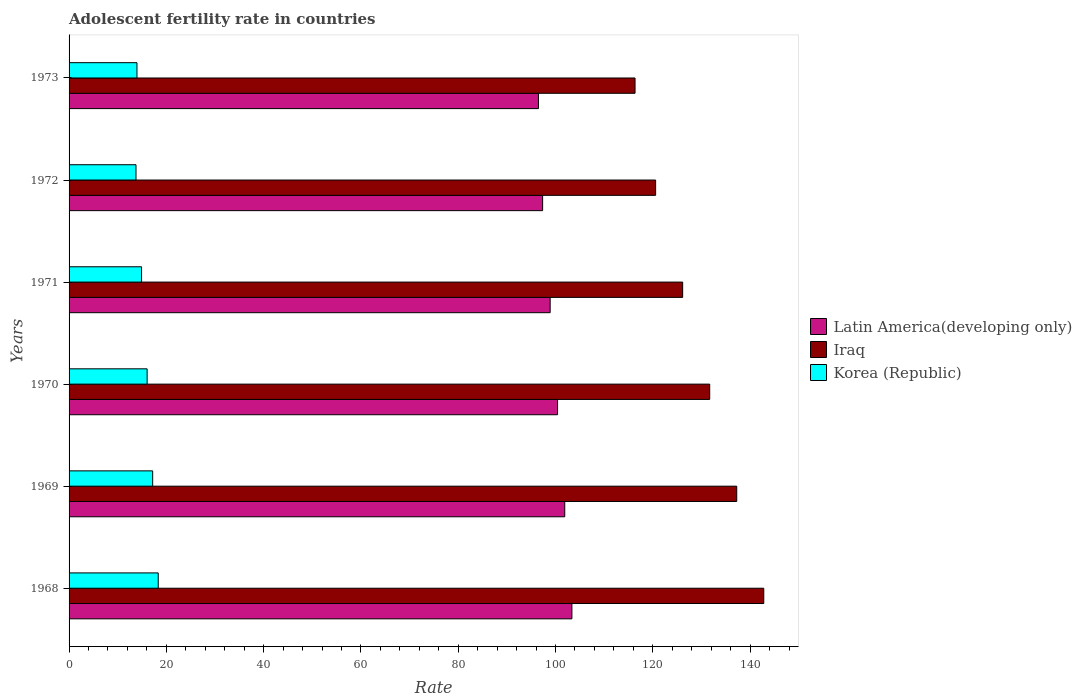How many different coloured bars are there?
Your response must be concise. 3. How many groups of bars are there?
Ensure brevity in your answer.  6. Are the number of bars per tick equal to the number of legend labels?
Ensure brevity in your answer.  Yes. Are the number of bars on each tick of the Y-axis equal?
Your response must be concise. Yes. What is the label of the 4th group of bars from the top?
Offer a terse response. 1970. In how many cases, is the number of bars for a given year not equal to the number of legend labels?
Your answer should be compact. 0. What is the adolescent fertility rate in Korea (Republic) in 1971?
Provide a short and direct response. 14.9. Across all years, what is the maximum adolescent fertility rate in Korea (Republic)?
Provide a short and direct response. 18.33. Across all years, what is the minimum adolescent fertility rate in Iraq?
Your response must be concise. 116.35. In which year was the adolescent fertility rate in Korea (Republic) maximum?
Your answer should be very brief. 1968. What is the total adolescent fertility rate in Latin America(developing only) in the graph?
Provide a succinct answer. 598.43. What is the difference between the adolescent fertility rate in Korea (Republic) in 1972 and that in 1973?
Make the answer very short. -0.2. What is the difference between the adolescent fertility rate in Latin America(developing only) in 1971 and the adolescent fertility rate in Iraq in 1972?
Your answer should be very brief. -21.68. What is the average adolescent fertility rate in Korea (Republic) per year?
Your answer should be compact. 15.7. In the year 1972, what is the difference between the adolescent fertility rate in Korea (Republic) and adolescent fertility rate in Latin America(developing only)?
Your answer should be compact. -83.59. What is the ratio of the adolescent fertility rate in Korea (Republic) in 1969 to that in 1972?
Offer a terse response. 1.25. Is the difference between the adolescent fertility rate in Korea (Republic) in 1968 and 1971 greater than the difference between the adolescent fertility rate in Latin America(developing only) in 1968 and 1971?
Offer a very short reply. No. What is the difference between the highest and the second highest adolescent fertility rate in Iraq?
Make the answer very short. 5.56. What is the difference between the highest and the lowest adolescent fertility rate in Latin America(developing only)?
Keep it short and to the point. 6.88. In how many years, is the adolescent fertility rate in Korea (Republic) greater than the average adolescent fertility rate in Korea (Republic) taken over all years?
Keep it short and to the point. 3. Is the sum of the adolescent fertility rate in Iraq in 1970 and 1972 greater than the maximum adolescent fertility rate in Korea (Republic) across all years?
Provide a succinct answer. Yes. What does the 2nd bar from the top in 1969 represents?
Keep it short and to the point. Iraq. What does the 2nd bar from the bottom in 1970 represents?
Provide a short and direct response. Iraq. Are all the bars in the graph horizontal?
Make the answer very short. Yes. How many years are there in the graph?
Keep it short and to the point. 6. Are the values on the major ticks of X-axis written in scientific E-notation?
Provide a succinct answer. No. Does the graph contain grids?
Make the answer very short. No. Where does the legend appear in the graph?
Offer a very short reply. Center right. How are the legend labels stacked?
Offer a terse response. Vertical. What is the title of the graph?
Make the answer very short. Adolescent fertility rate in countries. Does "Liechtenstein" appear as one of the legend labels in the graph?
Make the answer very short. No. What is the label or title of the X-axis?
Offer a terse response. Rate. What is the Rate of Latin America(developing only) in 1968?
Keep it short and to the point. 103.37. What is the Rate in Iraq in 1968?
Your answer should be very brief. 142.81. What is the Rate in Korea (Republic) in 1968?
Offer a terse response. 18.33. What is the Rate in Latin America(developing only) in 1969?
Offer a very short reply. 101.9. What is the Rate in Iraq in 1969?
Make the answer very short. 137.25. What is the Rate of Korea (Republic) in 1969?
Make the answer very short. 17.19. What is the Rate in Latin America(developing only) in 1970?
Ensure brevity in your answer.  100.42. What is the Rate in Iraq in 1970?
Give a very brief answer. 131.7. What is the Rate of Korea (Republic) in 1970?
Provide a succinct answer. 16.04. What is the Rate in Latin America(developing only) in 1971?
Give a very brief answer. 98.9. What is the Rate in Iraq in 1971?
Ensure brevity in your answer.  126.14. What is the Rate of Korea (Republic) in 1971?
Your response must be concise. 14.9. What is the Rate in Latin America(developing only) in 1972?
Offer a terse response. 97.35. What is the Rate of Iraq in 1972?
Give a very brief answer. 120.58. What is the Rate of Korea (Republic) in 1972?
Make the answer very short. 13.76. What is the Rate in Latin America(developing only) in 1973?
Your answer should be very brief. 96.49. What is the Rate in Iraq in 1973?
Provide a succinct answer. 116.35. What is the Rate of Korea (Republic) in 1973?
Your answer should be compact. 13.96. Across all years, what is the maximum Rate of Latin America(developing only)?
Give a very brief answer. 103.37. Across all years, what is the maximum Rate in Iraq?
Ensure brevity in your answer.  142.81. Across all years, what is the maximum Rate in Korea (Republic)?
Keep it short and to the point. 18.33. Across all years, what is the minimum Rate in Latin America(developing only)?
Offer a very short reply. 96.49. Across all years, what is the minimum Rate in Iraq?
Provide a succinct answer. 116.35. Across all years, what is the minimum Rate in Korea (Republic)?
Offer a very short reply. 13.76. What is the total Rate in Latin America(developing only) in the graph?
Your answer should be compact. 598.43. What is the total Rate in Iraq in the graph?
Your answer should be very brief. 774.83. What is the total Rate of Korea (Republic) in the graph?
Provide a short and direct response. 94.18. What is the difference between the Rate of Latin America(developing only) in 1968 and that in 1969?
Offer a very short reply. 1.47. What is the difference between the Rate of Iraq in 1968 and that in 1969?
Provide a short and direct response. 5.56. What is the difference between the Rate in Korea (Republic) in 1968 and that in 1969?
Offer a terse response. 1.14. What is the difference between the Rate in Latin America(developing only) in 1968 and that in 1970?
Provide a short and direct response. 2.95. What is the difference between the Rate of Iraq in 1968 and that in 1970?
Make the answer very short. 11.12. What is the difference between the Rate in Korea (Republic) in 1968 and that in 1970?
Ensure brevity in your answer.  2.29. What is the difference between the Rate of Latin America(developing only) in 1968 and that in 1971?
Your response must be concise. 4.47. What is the difference between the Rate of Iraq in 1968 and that in 1971?
Your response must be concise. 16.67. What is the difference between the Rate in Korea (Republic) in 1968 and that in 1971?
Your answer should be very brief. 3.43. What is the difference between the Rate in Latin America(developing only) in 1968 and that in 1972?
Provide a succinct answer. 6.02. What is the difference between the Rate of Iraq in 1968 and that in 1972?
Your answer should be very brief. 22.23. What is the difference between the Rate of Korea (Republic) in 1968 and that in 1972?
Offer a very short reply. 4.57. What is the difference between the Rate of Latin America(developing only) in 1968 and that in 1973?
Your response must be concise. 6.88. What is the difference between the Rate in Iraq in 1968 and that in 1973?
Offer a very short reply. 26.46. What is the difference between the Rate of Korea (Republic) in 1968 and that in 1973?
Your answer should be very brief. 4.37. What is the difference between the Rate of Latin America(developing only) in 1969 and that in 1970?
Your answer should be compact. 1.48. What is the difference between the Rate of Iraq in 1969 and that in 1970?
Your answer should be very brief. 5.56. What is the difference between the Rate in Korea (Republic) in 1969 and that in 1970?
Offer a very short reply. 1.14. What is the difference between the Rate in Latin America(developing only) in 1969 and that in 1971?
Make the answer very short. 3. What is the difference between the Rate in Iraq in 1969 and that in 1971?
Provide a short and direct response. 11.12. What is the difference between the Rate in Korea (Republic) in 1969 and that in 1971?
Your response must be concise. 2.29. What is the difference between the Rate in Latin America(developing only) in 1969 and that in 1972?
Provide a succinct answer. 4.55. What is the difference between the Rate of Iraq in 1969 and that in 1972?
Make the answer very short. 16.67. What is the difference between the Rate in Korea (Republic) in 1969 and that in 1972?
Offer a very short reply. 3.43. What is the difference between the Rate of Latin America(developing only) in 1969 and that in 1973?
Give a very brief answer. 5.41. What is the difference between the Rate of Iraq in 1969 and that in 1973?
Make the answer very short. 20.9. What is the difference between the Rate in Korea (Republic) in 1969 and that in 1973?
Offer a terse response. 3.23. What is the difference between the Rate of Latin America(developing only) in 1970 and that in 1971?
Offer a very short reply. 1.52. What is the difference between the Rate in Iraq in 1970 and that in 1971?
Offer a very short reply. 5.56. What is the difference between the Rate in Korea (Republic) in 1970 and that in 1971?
Provide a succinct answer. 1.14. What is the difference between the Rate of Latin America(developing only) in 1970 and that in 1972?
Your answer should be very brief. 3.07. What is the difference between the Rate in Iraq in 1970 and that in 1972?
Ensure brevity in your answer.  11.12. What is the difference between the Rate in Korea (Republic) in 1970 and that in 1972?
Offer a terse response. 2.29. What is the difference between the Rate in Latin America(developing only) in 1970 and that in 1973?
Your answer should be compact. 3.93. What is the difference between the Rate in Iraq in 1970 and that in 1973?
Make the answer very short. 15.35. What is the difference between the Rate in Korea (Republic) in 1970 and that in 1973?
Your answer should be compact. 2.09. What is the difference between the Rate of Latin America(developing only) in 1971 and that in 1972?
Keep it short and to the point. 1.55. What is the difference between the Rate in Iraq in 1971 and that in 1972?
Your answer should be very brief. 5.56. What is the difference between the Rate of Korea (Republic) in 1971 and that in 1972?
Your response must be concise. 1.14. What is the difference between the Rate in Latin America(developing only) in 1971 and that in 1973?
Your answer should be compact. 2.4. What is the difference between the Rate in Iraq in 1971 and that in 1973?
Provide a succinct answer. 9.79. What is the difference between the Rate in Korea (Republic) in 1971 and that in 1973?
Offer a very short reply. 0.94. What is the difference between the Rate of Latin America(developing only) in 1972 and that in 1973?
Provide a succinct answer. 0.86. What is the difference between the Rate in Iraq in 1972 and that in 1973?
Ensure brevity in your answer.  4.23. What is the difference between the Rate in Korea (Republic) in 1972 and that in 1973?
Ensure brevity in your answer.  -0.2. What is the difference between the Rate of Latin America(developing only) in 1968 and the Rate of Iraq in 1969?
Offer a very short reply. -33.88. What is the difference between the Rate of Latin America(developing only) in 1968 and the Rate of Korea (Republic) in 1969?
Offer a terse response. 86.18. What is the difference between the Rate in Iraq in 1968 and the Rate in Korea (Republic) in 1969?
Offer a very short reply. 125.62. What is the difference between the Rate of Latin America(developing only) in 1968 and the Rate of Iraq in 1970?
Your answer should be compact. -28.33. What is the difference between the Rate in Latin America(developing only) in 1968 and the Rate in Korea (Republic) in 1970?
Offer a very short reply. 87.33. What is the difference between the Rate of Iraq in 1968 and the Rate of Korea (Republic) in 1970?
Give a very brief answer. 126.77. What is the difference between the Rate in Latin America(developing only) in 1968 and the Rate in Iraq in 1971?
Offer a very short reply. -22.77. What is the difference between the Rate in Latin America(developing only) in 1968 and the Rate in Korea (Republic) in 1971?
Ensure brevity in your answer.  88.47. What is the difference between the Rate of Iraq in 1968 and the Rate of Korea (Republic) in 1971?
Your answer should be compact. 127.91. What is the difference between the Rate of Latin America(developing only) in 1968 and the Rate of Iraq in 1972?
Ensure brevity in your answer.  -17.21. What is the difference between the Rate of Latin America(developing only) in 1968 and the Rate of Korea (Republic) in 1972?
Ensure brevity in your answer.  89.61. What is the difference between the Rate in Iraq in 1968 and the Rate in Korea (Republic) in 1972?
Ensure brevity in your answer.  129.05. What is the difference between the Rate of Latin America(developing only) in 1968 and the Rate of Iraq in 1973?
Offer a very short reply. -12.98. What is the difference between the Rate in Latin America(developing only) in 1968 and the Rate in Korea (Republic) in 1973?
Keep it short and to the point. 89.41. What is the difference between the Rate of Iraq in 1968 and the Rate of Korea (Republic) in 1973?
Keep it short and to the point. 128.85. What is the difference between the Rate of Latin America(developing only) in 1969 and the Rate of Iraq in 1970?
Ensure brevity in your answer.  -29.8. What is the difference between the Rate in Latin America(developing only) in 1969 and the Rate in Korea (Republic) in 1970?
Offer a very short reply. 85.86. What is the difference between the Rate of Iraq in 1969 and the Rate of Korea (Republic) in 1970?
Your answer should be very brief. 121.21. What is the difference between the Rate in Latin America(developing only) in 1969 and the Rate in Iraq in 1971?
Give a very brief answer. -24.24. What is the difference between the Rate in Latin America(developing only) in 1969 and the Rate in Korea (Republic) in 1971?
Offer a very short reply. 87. What is the difference between the Rate of Iraq in 1969 and the Rate of Korea (Republic) in 1971?
Offer a very short reply. 122.35. What is the difference between the Rate of Latin America(developing only) in 1969 and the Rate of Iraq in 1972?
Provide a succinct answer. -18.68. What is the difference between the Rate in Latin America(developing only) in 1969 and the Rate in Korea (Republic) in 1972?
Make the answer very short. 88.14. What is the difference between the Rate of Iraq in 1969 and the Rate of Korea (Republic) in 1972?
Give a very brief answer. 123.49. What is the difference between the Rate in Latin America(developing only) in 1969 and the Rate in Iraq in 1973?
Offer a terse response. -14.45. What is the difference between the Rate of Latin America(developing only) in 1969 and the Rate of Korea (Republic) in 1973?
Offer a terse response. 87.94. What is the difference between the Rate in Iraq in 1969 and the Rate in Korea (Republic) in 1973?
Your answer should be very brief. 123.3. What is the difference between the Rate of Latin America(developing only) in 1970 and the Rate of Iraq in 1971?
Ensure brevity in your answer.  -25.72. What is the difference between the Rate in Latin America(developing only) in 1970 and the Rate in Korea (Republic) in 1971?
Your answer should be compact. 85.52. What is the difference between the Rate of Iraq in 1970 and the Rate of Korea (Republic) in 1971?
Provide a succinct answer. 116.79. What is the difference between the Rate of Latin America(developing only) in 1970 and the Rate of Iraq in 1972?
Provide a short and direct response. -20.16. What is the difference between the Rate of Latin America(developing only) in 1970 and the Rate of Korea (Republic) in 1972?
Ensure brevity in your answer.  86.66. What is the difference between the Rate of Iraq in 1970 and the Rate of Korea (Republic) in 1972?
Your response must be concise. 117.94. What is the difference between the Rate in Latin America(developing only) in 1970 and the Rate in Iraq in 1973?
Your answer should be compact. -15.93. What is the difference between the Rate of Latin America(developing only) in 1970 and the Rate of Korea (Republic) in 1973?
Provide a succinct answer. 86.46. What is the difference between the Rate of Iraq in 1970 and the Rate of Korea (Republic) in 1973?
Keep it short and to the point. 117.74. What is the difference between the Rate of Latin America(developing only) in 1971 and the Rate of Iraq in 1972?
Offer a terse response. -21.68. What is the difference between the Rate in Latin America(developing only) in 1971 and the Rate in Korea (Republic) in 1972?
Keep it short and to the point. 85.14. What is the difference between the Rate of Iraq in 1971 and the Rate of Korea (Republic) in 1972?
Provide a succinct answer. 112.38. What is the difference between the Rate in Latin America(developing only) in 1971 and the Rate in Iraq in 1973?
Give a very brief answer. -17.45. What is the difference between the Rate of Latin America(developing only) in 1971 and the Rate of Korea (Republic) in 1973?
Make the answer very short. 84.94. What is the difference between the Rate of Iraq in 1971 and the Rate of Korea (Republic) in 1973?
Your response must be concise. 112.18. What is the difference between the Rate in Latin America(developing only) in 1972 and the Rate in Iraq in 1973?
Your answer should be compact. -19. What is the difference between the Rate of Latin America(developing only) in 1972 and the Rate of Korea (Republic) in 1973?
Give a very brief answer. 83.39. What is the difference between the Rate of Iraq in 1972 and the Rate of Korea (Republic) in 1973?
Provide a short and direct response. 106.62. What is the average Rate in Latin America(developing only) per year?
Offer a very short reply. 99.74. What is the average Rate in Iraq per year?
Provide a succinct answer. 129.14. What is the average Rate in Korea (Republic) per year?
Your answer should be very brief. 15.7. In the year 1968, what is the difference between the Rate in Latin America(developing only) and Rate in Iraq?
Give a very brief answer. -39.44. In the year 1968, what is the difference between the Rate of Latin America(developing only) and Rate of Korea (Republic)?
Your response must be concise. 85.04. In the year 1968, what is the difference between the Rate of Iraq and Rate of Korea (Republic)?
Keep it short and to the point. 124.48. In the year 1969, what is the difference between the Rate of Latin America(developing only) and Rate of Iraq?
Offer a very short reply. -35.35. In the year 1969, what is the difference between the Rate of Latin America(developing only) and Rate of Korea (Republic)?
Provide a short and direct response. 84.71. In the year 1969, what is the difference between the Rate of Iraq and Rate of Korea (Republic)?
Provide a short and direct response. 120.07. In the year 1970, what is the difference between the Rate of Latin America(developing only) and Rate of Iraq?
Provide a succinct answer. -31.27. In the year 1970, what is the difference between the Rate of Latin America(developing only) and Rate of Korea (Republic)?
Keep it short and to the point. 84.38. In the year 1970, what is the difference between the Rate of Iraq and Rate of Korea (Republic)?
Provide a succinct answer. 115.65. In the year 1971, what is the difference between the Rate in Latin America(developing only) and Rate in Iraq?
Provide a short and direct response. -27.24. In the year 1971, what is the difference between the Rate of Latin America(developing only) and Rate of Korea (Republic)?
Give a very brief answer. 84. In the year 1971, what is the difference between the Rate in Iraq and Rate in Korea (Republic)?
Provide a succinct answer. 111.24. In the year 1972, what is the difference between the Rate in Latin America(developing only) and Rate in Iraq?
Your answer should be compact. -23.23. In the year 1972, what is the difference between the Rate in Latin America(developing only) and Rate in Korea (Republic)?
Keep it short and to the point. 83.59. In the year 1972, what is the difference between the Rate of Iraq and Rate of Korea (Republic)?
Provide a succinct answer. 106.82. In the year 1973, what is the difference between the Rate in Latin America(developing only) and Rate in Iraq?
Offer a very short reply. -19.86. In the year 1973, what is the difference between the Rate of Latin America(developing only) and Rate of Korea (Republic)?
Your answer should be very brief. 82.53. In the year 1973, what is the difference between the Rate in Iraq and Rate in Korea (Republic)?
Your answer should be compact. 102.39. What is the ratio of the Rate of Latin America(developing only) in 1968 to that in 1969?
Provide a succinct answer. 1.01. What is the ratio of the Rate of Iraq in 1968 to that in 1969?
Provide a short and direct response. 1.04. What is the ratio of the Rate in Korea (Republic) in 1968 to that in 1969?
Provide a short and direct response. 1.07. What is the ratio of the Rate of Latin America(developing only) in 1968 to that in 1970?
Ensure brevity in your answer.  1.03. What is the ratio of the Rate in Iraq in 1968 to that in 1970?
Make the answer very short. 1.08. What is the ratio of the Rate of Korea (Republic) in 1968 to that in 1970?
Provide a short and direct response. 1.14. What is the ratio of the Rate of Latin America(developing only) in 1968 to that in 1971?
Your answer should be compact. 1.05. What is the ratio of the Rate of Iraq in 1968 to that in 1971?
Make the answer very short. 1.13. What is the ratio of the Rate in Korea (Republic) in 1968 to that in 1971?
Offer a terse response. 1.23. What is the ratio of the Rate of Latin America(developing only) in 1968 to that in 1972?
Give a very brief answer. 1.06. What is the ratio of the Rate in Iraq in 1968 to that in 1972?
Your answer should be very brief. 1.18. What is the ratio of the Rate of Korea (Republic) in 1968 to that in 1972?
Provide a succinct answer. 1.33. What is the ratio of the Rate of Latin America(developing only) in 1968 to that in 1973?
Your answer should be very brief. 1.07. What is the ratio of the Rate of Iraq in 1968 to that in 1973?
Keep it short and to the point. 1.23. What is the ratio of the Rate in Korea (Republic) in 1968 to that in 1973?
Your answer should be compact. 1.31. What is the ratio of the Rate of Latin America(developing only) in 1969 to that in 1970?
Provide a succinct answer. 1.01. What is the ratio of the Rate in Iraq in 1969 to that in 1970?
Provide a succinct answer. 1.04. What is the ratio of the Rate of Korea (Republic) in 1969 to that in 1970?
Give a very brief answer. 1.07. What is the ratio of the Rate of Latin America(developing only) in 1969 to that in 1971?
Make the answer very short. 1.03. What is the ratio of the Rate of Iraq in 1969 to that in 1971?
Make the answer very short. 1.09. What is the ratio of the Rate in Korea (Republic) in 1969 to that in 1971?
Make the answer very short. 1.15. What is the ratio of the Rate in Latin America(developing only) in 1969 to that in 1972?
Your answer should be very brief. 1.05. What is the ratio of the Rate of Iraq in 1969 to that in 1972?
Provide a succinct answer. 1.14. What is the ratio of the Rate of Korea (Republic) in 1969 to that in 1972?
Give a very brief answer. 1.25. What is the ratio of the Rate of Latin America(developing only) in 1969 to that in 1973?
Your response must be concise. 1.06. What is the ratio of the Rate in Iraq in 1969 to that in 1973?
Your answer should be compact. 1.18. What is the ratio of the Rate in Korea (Republic) in 1969 to that in 1973?
Offer a terse response. 1.23. What is the ratio of the Rate of Latin America(developing only) in 1970 to that in 1971?
Provide a short and direct response. 1.02. What is the ratio of the Rate of Iraq in 1970 to that in 1971?
Give a very brief answer. 1.04. What is the ratio of the Rate in Korea (Republic) in 1970 to that in 1971?
Your answer should be very brief. 1.08. What is the ratio of the Rate of Latin America(developing only) in 1970 to that in 1972?
Give a very brief answer. 1.03. What is the ratio of the Rate of Iraq in 1970 to that in 1972?
Keep it short and to the point. 1.09. What is the ratio of the Rate of Korea (Republic) in 1970 to that in 1972?
Your answer should be very brief. 1.17. What is the ratio of the Rate in Latin America(developing only) in 1970 to that in 1973?
Offer a very short reply. 1.04. What is the ratio of the Rate of Iraq in 1970 to that in 1973?
Your answer should be very brief. 1.13. What is the ratio of the Rate in Korea (Republic) in 1970 to that in 1973?
Offer a terse response. 1.15. What is the ratio of the Rate of Latin America(developing only) in 1971 to that in 1972?
Your answer should be compact. 1.02. What is the ratio of the Rate in Iraq in 1971 to that in 1972?
Ensure brevity in your answer.  1.05. What is the ratio of the Rate in Korea (Republic) in 1971 to that in 1972?
Your answer should be compact. 1.08. What is the ratio of the Rate in Latin America(developing only) in 1971 to that in 1973?
Provide a short and direct response. 1.02. What is the ratio of the Rate of Iraq in 1971 to that in 1973?
Provide a succinct answer. 1.08. What is the ratio of the Rate of Korea (Republic) in 1971 to that in 1973?
Offer a very short reply. 1.07. What is the ratio of the Rate in Latin America(developing only) in 1972 to that in 1973?
Keep it short and to the point. 1.01. What is the ratio of the Rate in Iraq in 1972 to that in 1973?
Your response must be concise. 1.04. What is the ratio of the Rate in Korea (Republic) in 1972 to that in 1973?
Give a very brief answer. 0.99. What is the difference between the highest and the second highest Rate of Latin America(developing only)?
Give a very brief answer. 1.47. What is the difference between the highest and the second highest Rate of Iraq?
Your answer should be compact. 5.56. What is the difference between the highest and the second highest Rate of Korea (Republic)?
Your answer should be compact. 1.14. What is the difference between the highest and the lowest Rate of Latin America(developing only)?
Make the answer very short. 6.88. What is the difference between the highest and the lowest Rate in Iraq?
Offer a terse response. 26.46. What is the difference between the highest and the lowest Rate of Korea (Republic)?
Offer a terse response. 4.57. 